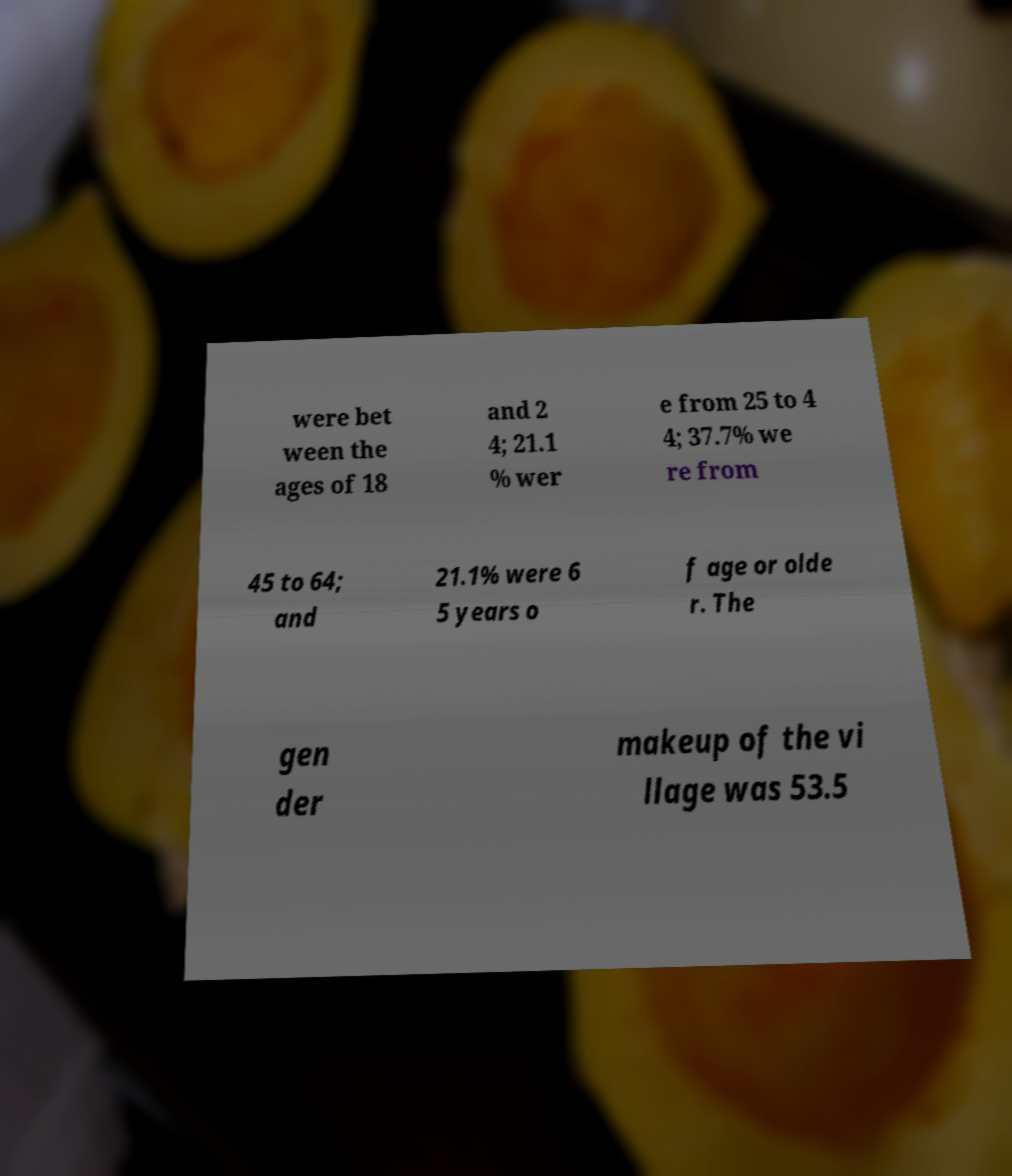What messages or text are displayed in this image? I need them in a readable, typed format. were bet ween the ages of 18 and 2 4; 21.1 % wer e from 25 to 4 4; 37.7% we re from 45 to 64; and 21.1% were 6 5 years o f age or olde r. The gen der makeup of the vi llage was 53.5 